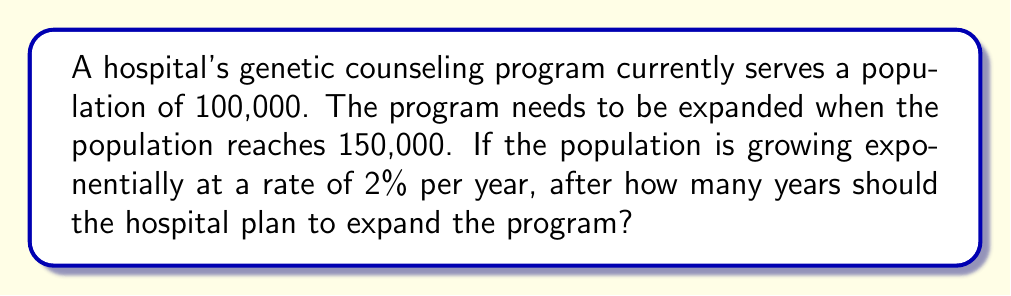Solve this math problem. Let's approach this step-by-step using the exponential growth formula:

1) The exponential growth formula is:
   $A = P(1 + r)^t$
   Where:
   $A$ = Final amount
   $P$ = Initial amount
   $r$ = Growth rate (as a decimal)
   $t$ = Time (in years)

2) We know:
   $P = 100,000$
   $A = 150,000$
   $r = 0.02$ (2% expressed as a decimal)

3) Let's substitute these into our formula:
   $150,000 = 100,000(1 + 0.02)^t$

4) Simplify:
   $1.5 = (1.02)^t$

5) Take the natural log of both sides:
   $\ln(1.5) = \ln((1.02)^t)$

6) Use the logarithm property $\ln(a^b) = b\ln(a)$:
   $\ln(1.5) = t\ln(1.02)$

7) Solve for $t$:
   $t = \frac{\ln(1.5)}{\ln(1.02)}$

8) Calculate:
   $t \approx 20.97$ years

9) Since we can't expand in a fraction of a year, we round up to the next whole year.
Answer: 21 years 